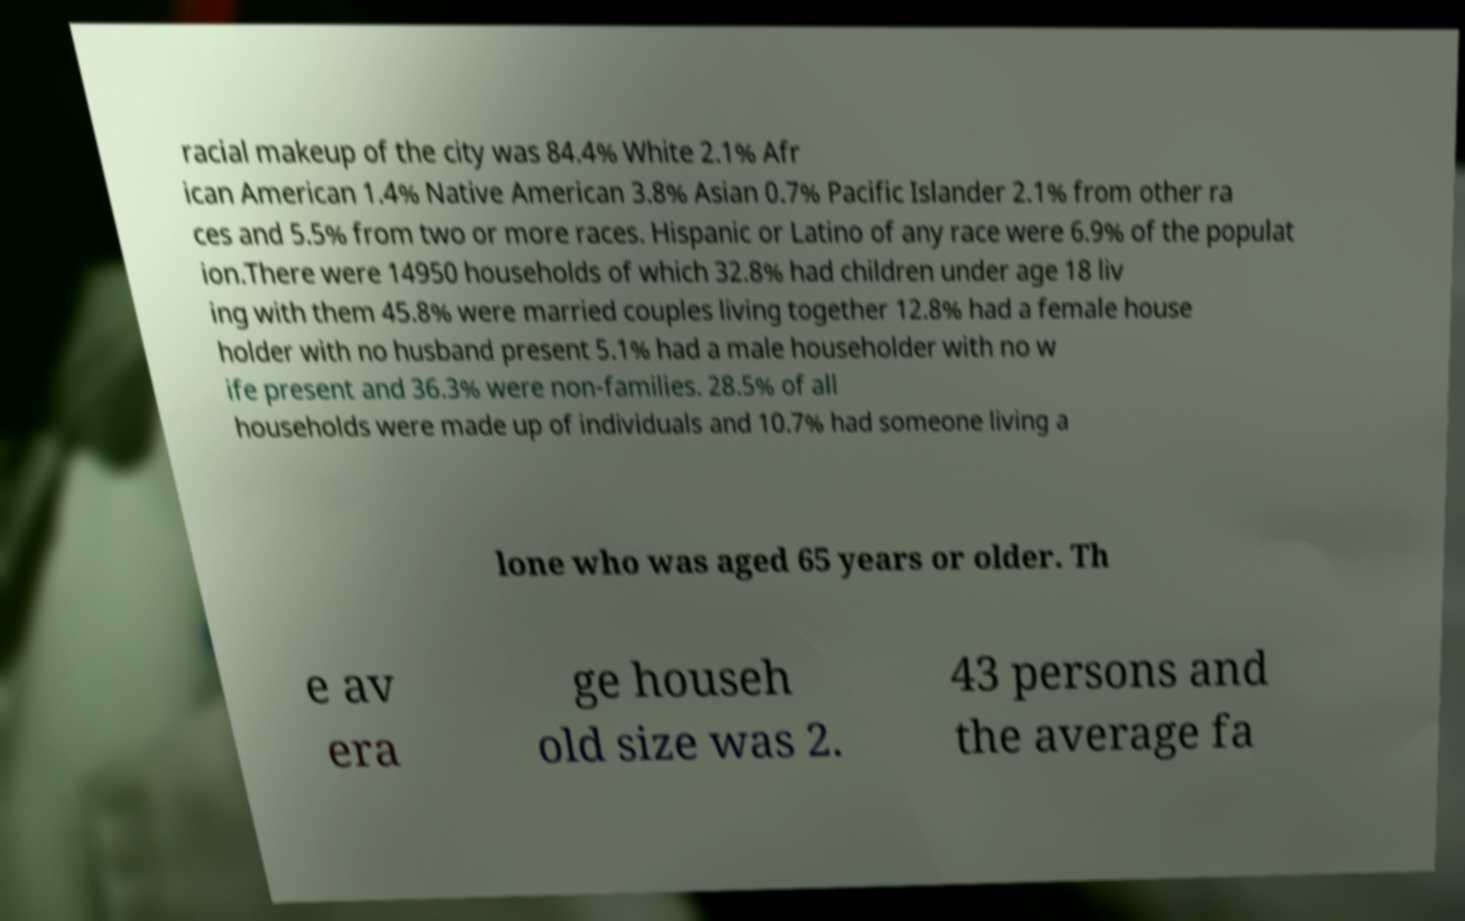Could you assist in decoding the text presented in this image and type it out clearly? racial makeup of the city was 84.4% White 2.1% Afr ican American 1.4% Native American 3.8% Asian 0.7% Pacific Islander 2.1% from other ra ces and 5.5% from two or more races. Hispanic or Latino of any race were 6.9% of the populat ion.There were 14950 households of which 32.8% had children under age 18 liv ing with them 45.8% were married couples living together 12.8% had a female house holder with no husband present 5.1% had a male householder with no w ife present and 36.3% were non-families. 28.5% of all households were made up of individuals and 10.7% had someone living a lone who was aged 65 years or older. Th e av era ge househ old size was 2. 43 persons and the average fa 